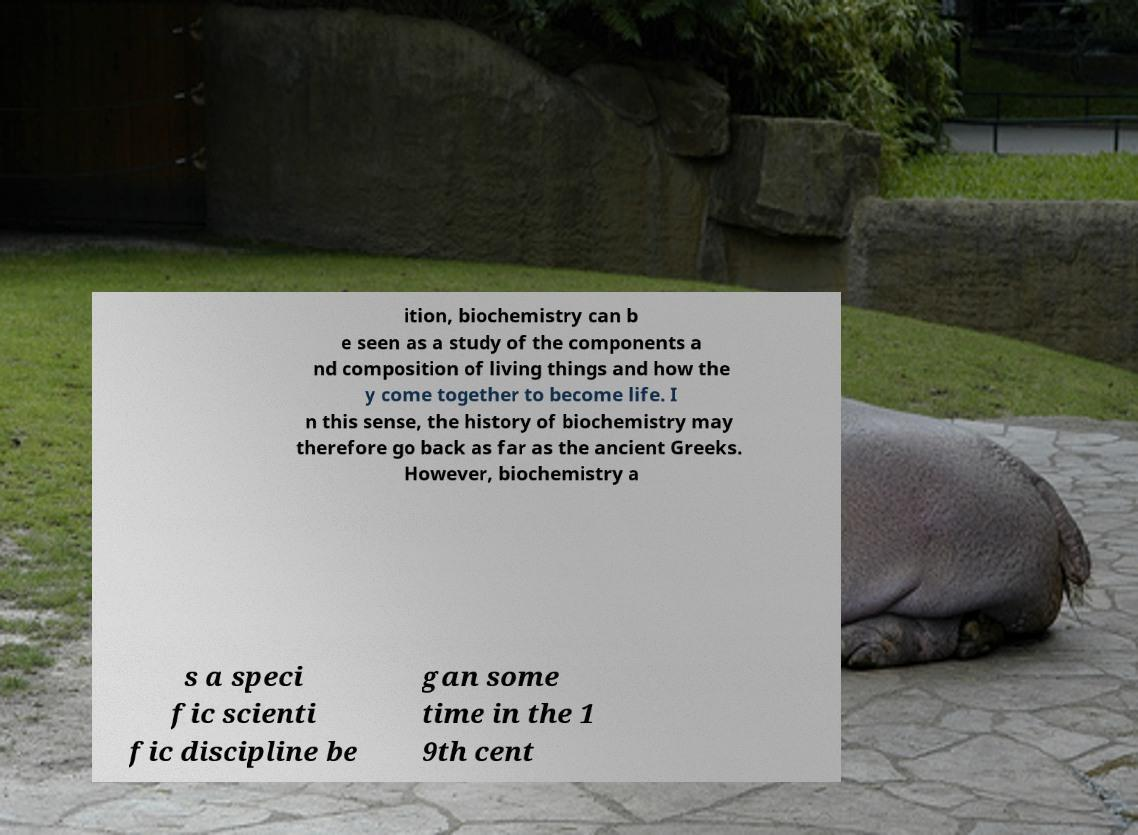What messages or text are displayed in this image? I need them in a readable, typed format. ition, biochemistry can b e seen as a study of the components a nd composition of living things and how the y come together to become life. I n this sense, the history of biochemistry may therefore go back as far as the ancient Greeks. However, biochemistry a s a speci fic scienti fic discipline be gan some time in the 1 9th cent 